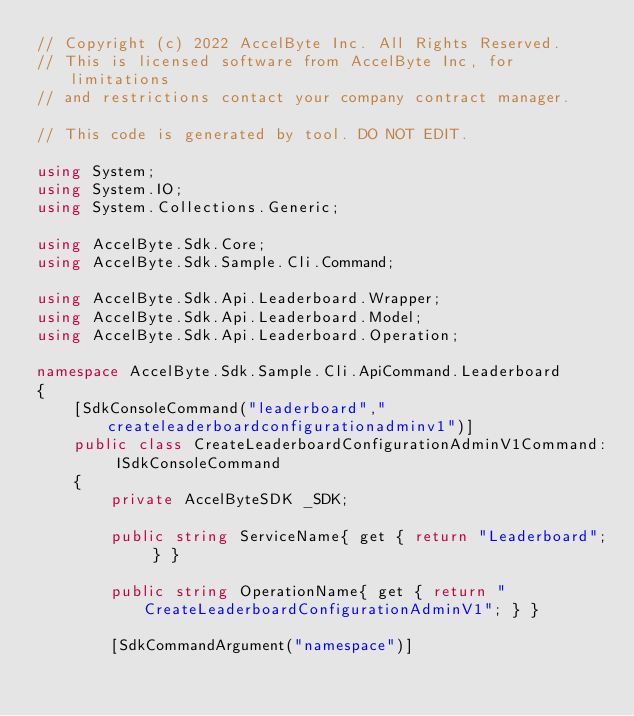<code> <loc_0><loc_0><loc_500><loc_500><_C#_>// Copyright (c) 2022 AccelByte Inc. All Rights Reserved.
// This is licensed software from AccelByte Inc, for limitations
// and restrictions contact your company contract manager.

// This code is generated by tool. DO NOT EDIT.

using System;
using System.IO;
using System.Collections.Generic;

using AccelByte.Sdk.Core;
using AccelByte.Sdk.Sample.Cli.Command;

using AccelByte.Sdk.Api.Leaderboard.Wrapper;
using AccelByte.Sdk.Api.Leaderboard.Model;
using AccelByte.Sdk.Api.Leaderboard.Operation;

namespace AccelByte.Sdk.Sample.Cli.ApiCommand.Leaderboard
{
    [SdkConsoleCommand("leaderboard","createleaderboardconfigurationadminv1")]
    public class CreateLeaderboardConfigurationAdminV1Command: ISdkConsoleCommand
    {
        private AccelByteSDK _SDK;

        public string ServiceName{ get { return "Leaderboard"; } }

        public string OperationName{ get { return "CreateLeaderboardConfigurationAdminV1"; } }

        [SdkCommandArgument("namespace")]</code> 